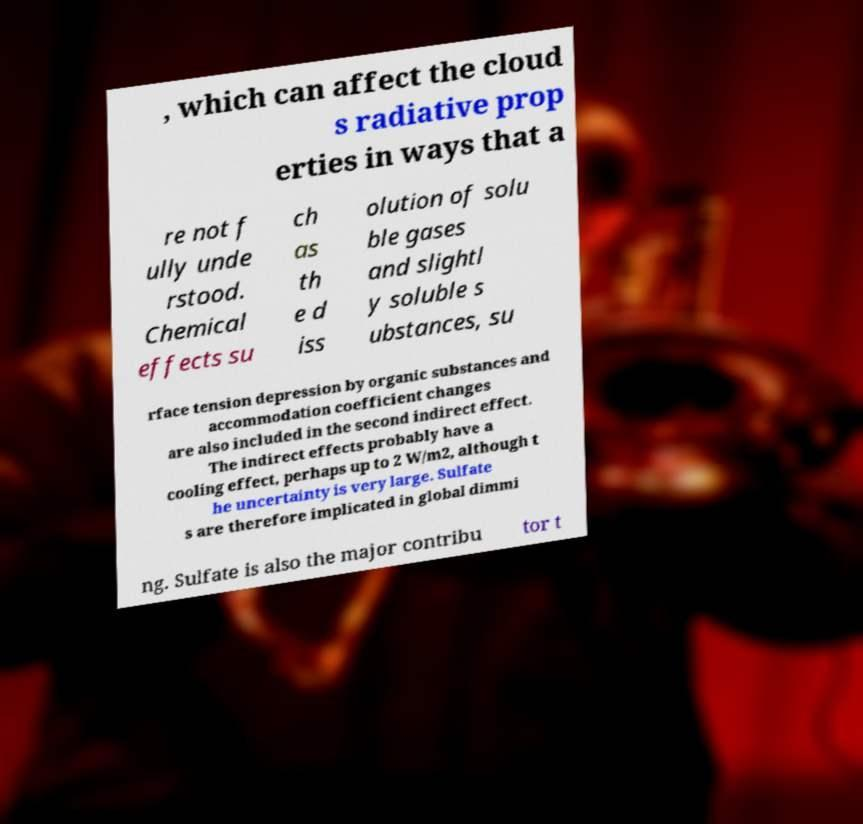Could you assist in decoding the text presented in this image and type it out clearly? , which can affect the cloud s radiative prop erties in ways that a re not f ully unde rstood. Chemical effects su ch as th e d iss olution of solu ble gases and slightl y soluble s ubstances, su rface tension depression by organic substances and accommodation coefficient changes are also included in the second indirect effect. The indirect effects probably have a cooling effect, perhaps up to 2 W/m2, although t he uncertainty is very large. Sulfate s are therefore implicated in global dimmi ng. Sulfate is also the major contribu tor t 